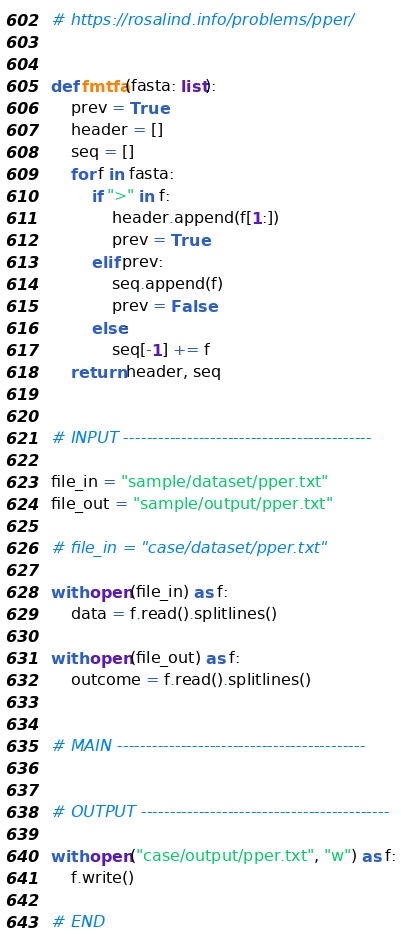<code> <loc_0><loc_0><loc_500><loc_500><_Python_># https://rosalind.info/problems/pper/


def fmtfa(fasta: list):
    prev = True
    header = []
    seq = []
    for f in fasta:
        if ">" in f:
            header.append(f[1:])
            prev = True
        elif prev:
            seq.append(f)
            prev = False
        else:
            seq[-1] += f
    return header, seq


# INPUT -------------------------------------------

file_in = "sample/dataset/pper.txt"
file_out = "sample/output/pper.txt"

# file_in = "case/dataset/pper.txt"

with open(file_in) as f:
    data = f.read().splitlines()

with open(file_out) as f:
    outcome = f.read().splitlines()


# MAIN -------------------------------------------


# OUTPUT -------------------------------------------

with open("case/output/pper.txt", "w") as f:
    f.write()

# END
</code> 